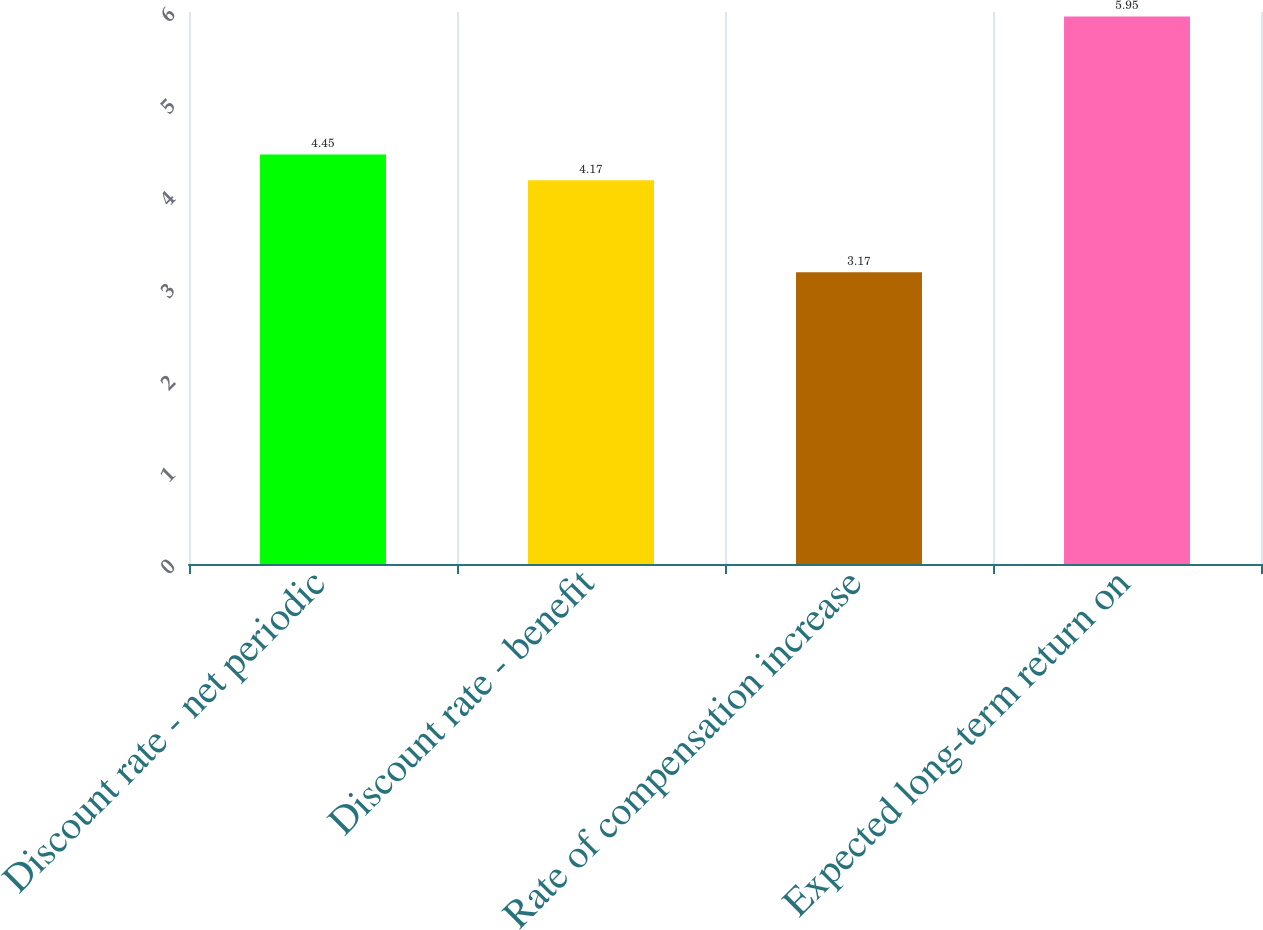<chart> <loc_0><loc_0><loc_500><loc_500><bar_chart><fcel>Discount rate - net periodic<fcel>Discount rate - benefit<fcel>Rate of compensation increase<fcel>Expected long-term return on<nl><fcel>4.45<fcel>4.17<fcel>3.17<fcel>5.95<nl></chart> 